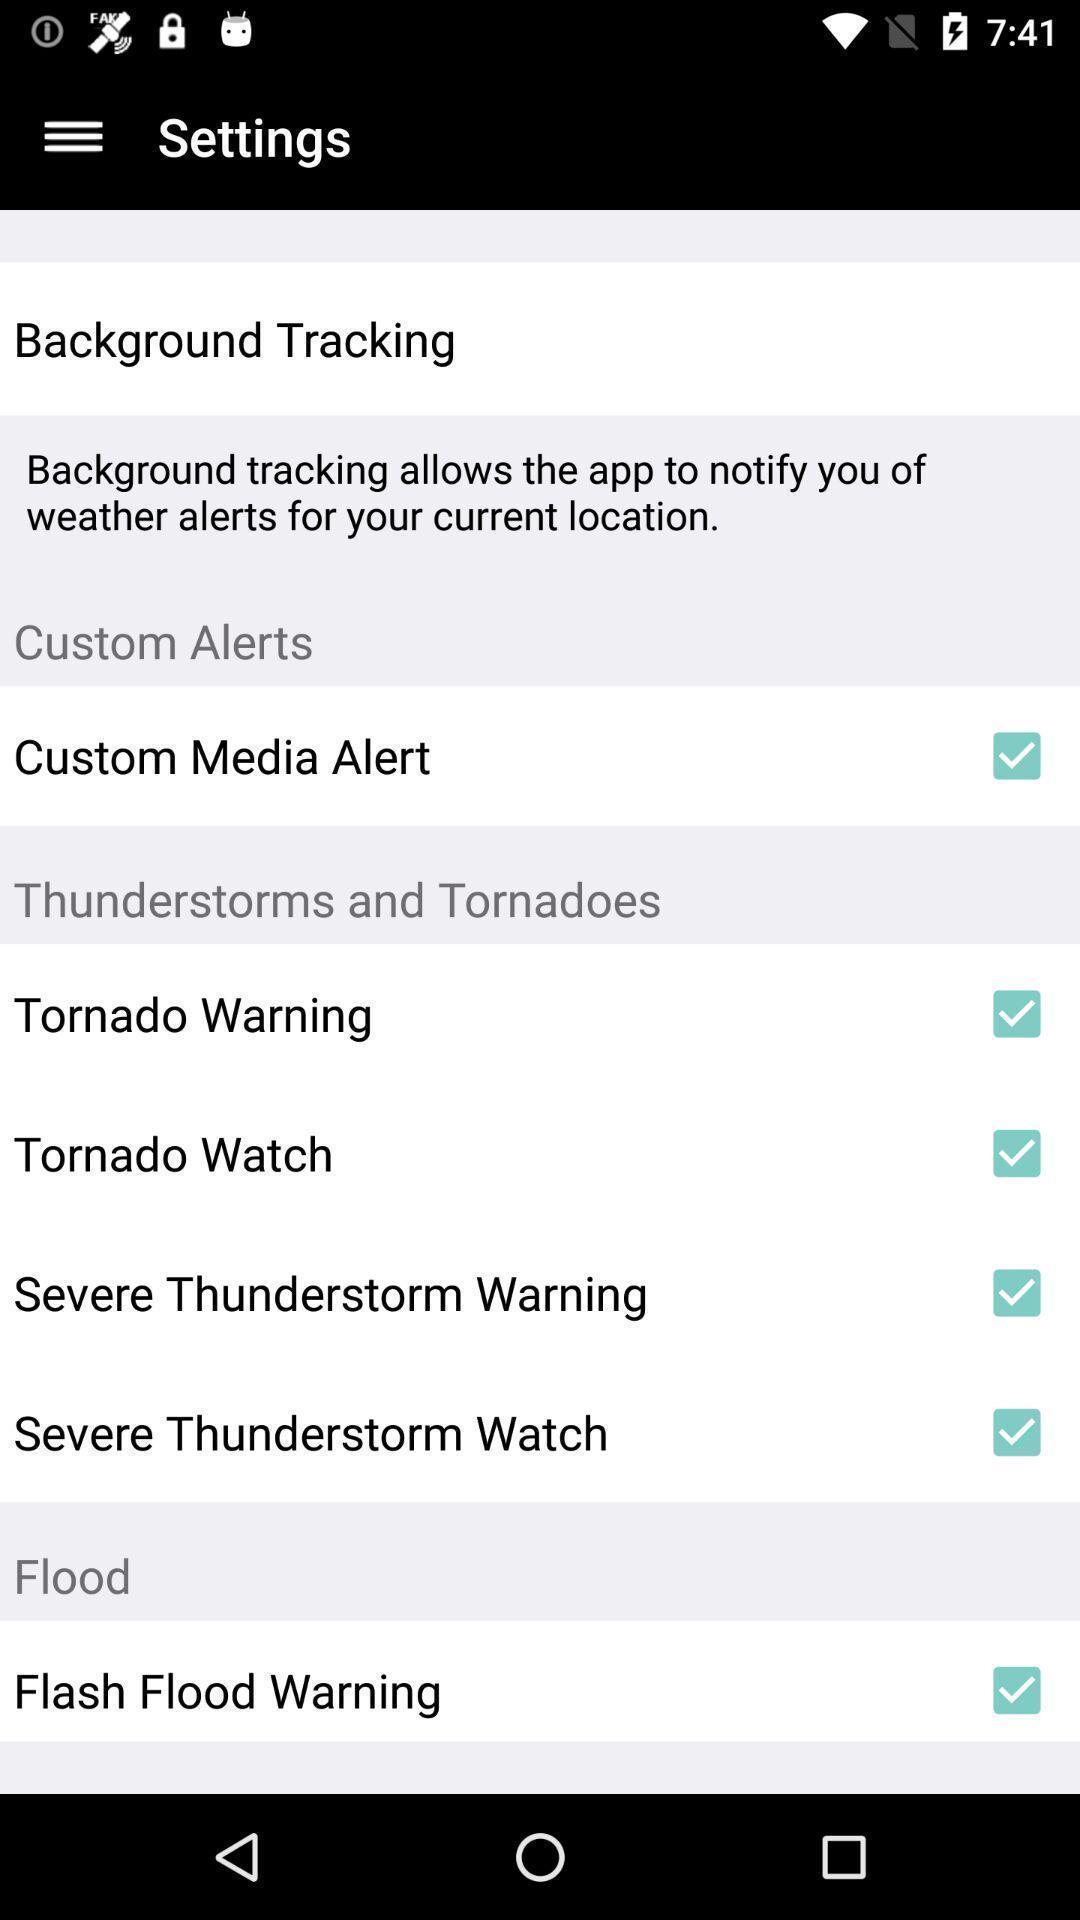Explain the elements present in this screenshot. Settings page with various other options. 